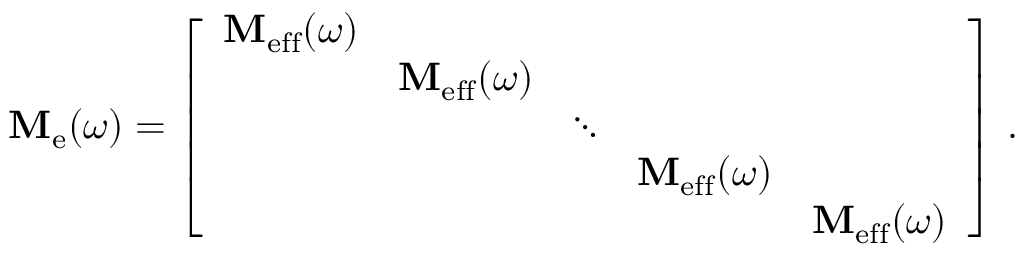Convert formula to latex. <formula><loc_0><loc_0><loc_500><loc_500>M _ { e } ( \omega ) = \left [ \begin{array} { l l l l l } { M _ { e f f } ( \omega ) } & & & & \\ & { M _ { e f f } ( \omega ) } & & & \\ & & { \ddots } & & \\ & & & { M _ { e f f } ( \omega ) } & \\ & & & & { M _ { e f f } ( \omega ) } \end{array} \right ] \, .</formula> 